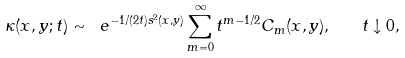Convert formula to latex. <formula><loc_0><loc_0><loc_500><loc_500>\kappa ( x , y ; t ) \sim \ e ^ { - { 1 } / ( { 2 t } ) s ^ { 2 } ( x , y ) } \sum _ { m = 0 } ^ { \infty } t ^ { m - 1 / 2 } C _ { m } ( x , y ) , \quad t \downarrow 0 ,</formula> 